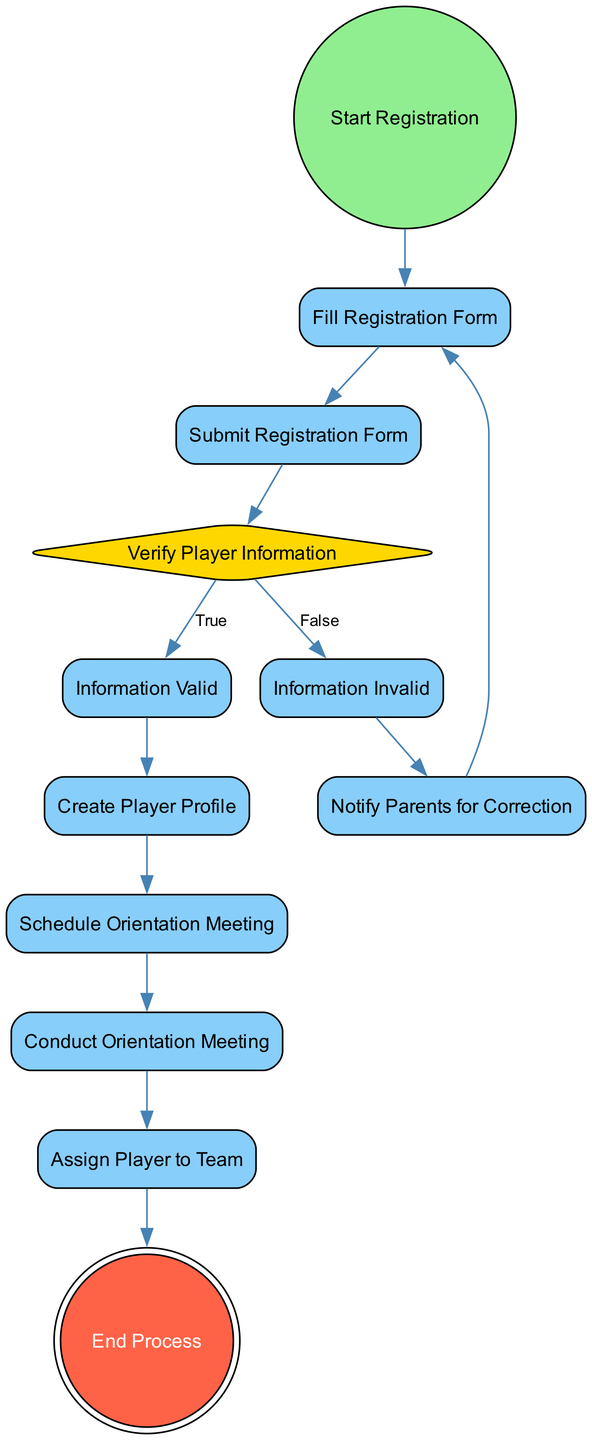What is the starting activity in the registration process? The diagram indicates that the starting activity is labeled "Start Registration," which is the initial node in the process.
Answer: Start Registration How many actions are involved in the process? By reviewing the diagram, it can be counted that there are a total of six action activities: "Fill Registration Form," "Submit Registration Form," "Information Valid," "Create Player Profile," "Schedule Orientation Meeting," "Conduct Orientation Meeting," and "Assign Player to Team."
Answer: 6 What happens if the player information is invalid? The diagram shows that if the player information is invalid, the process transitions to "Notify Parents for Correction," followed by a return to "Fill Registration Form" for correction.
Answer: Notify Parents for Correction What activity occurs after "Submit Registration Form"? Following the "Submit Registration Form" activity, the next activity in the flow is "Verify Player Information," indicating the step to check the submitted data.
Answer: Verify Player Information What is the final activity in the registration and onboarding process? The diagram specifies that the final activity, marking the end of the process, is titled "End Process," which signifies that all steps are completed.
Answer: End Process Which activity is assigned to players after verification is valid? Upon verifying that the player information is valid, the next action attributed to the player is "Create Player Profile," which is essential for their records within the system.
Answer: Create Player Profile If the information is invalid, how does the process continue? When the information is identified as invalid, the process directs to "Notify Parents for Correction," prompting them to amend the errors and resubmit the registration form.
Answer: Notify Parents for Correction What type of node is "Verify Player Information"? The diagram categorizes the "Verify Player Information" node as a decision point, indicated by its diamond shape, reflecting its role in determining the flow based on conditions.
Answer: Decision 